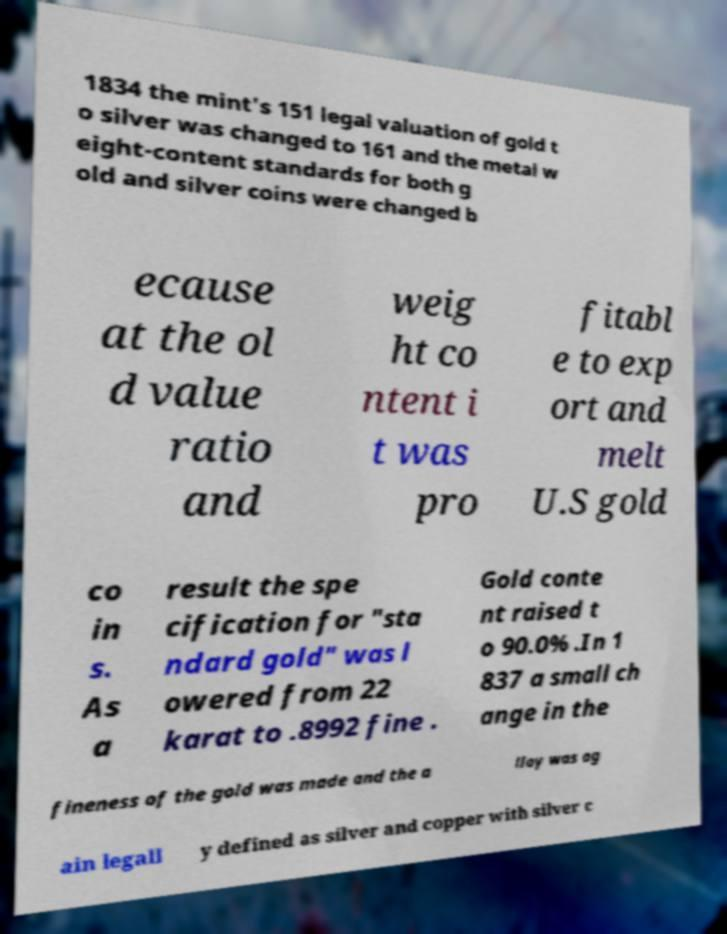Please read and relay the text visible in this image. What does it say? 1834 the mint's 151 legal valuation of gold t o silver was changed to 161 and the metal w eight-content standards for both g old and silver coins were changed b ecause at the ol d value ratio and weig ht co ntent i t was pro fitabl e to exp ort and melt U.S gold co in s. As a result the spe cification for "sta ndard gold" was l owered from 22 karat to .8992 fine . Gold conte nt raised t o 90.0% .In 1 837 a small ch ange in the fineness of the gold was made and the a lloy was ag ain legall y defined as silver and copper with silver c 